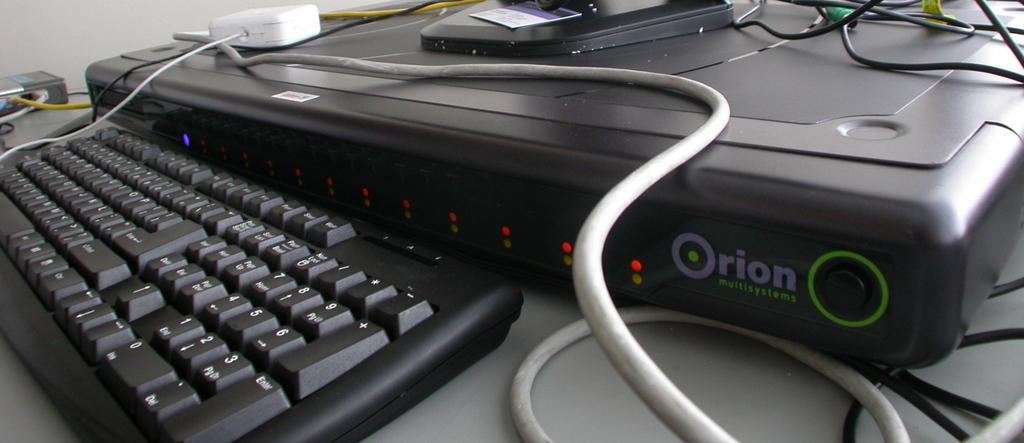<image>
Offer a succinct explanation of the picture presented. Orion device in front of a black keyboard. 